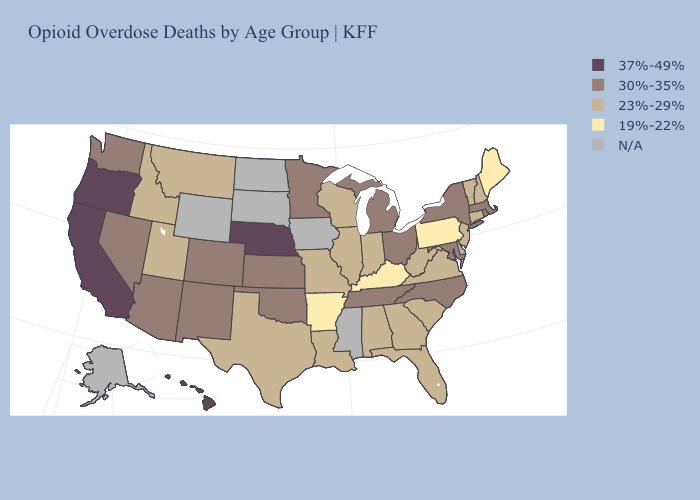Which states hav the highest value in the West?
Quick response, please. California, Hawaii, Oregon. What is the lowest value in the South?
Answer briefly. 19%-22%. Name the states that have a value in the range 30%-35%?
Be succinct. Arizona, Colorado, Kansas, Maryland, Massachusetts, Michigan, Minnesota, Nevada, New Mexico, New York, North Carolina, Ohio, Oklahoma, Rhode Island, Tennessee, Washington. Name the states that have a value in the range 23%-29%?
Quick response, please. Alabama, Connecticut, Florida, Georgia, Idaho, Illinois, Indiana, Louisiana, Missouri, Montana, New Hampshire, New Jersey, South Carolina, Texas, Utah, Vermont, Virginia, West Virginia, Wisconsin. Which states have the lowest value in the West?
Be succinct. Idaho, Montana, Utah. What is the value of Rhode Island?
Answer briefly. 30%-35%. Which states have the highest value in the USA?
Quick response, please. California, Hawaii, Nebraska, Oregon. Name the states that have a value in the range 30%-35%?
Be succinct. Arizona, Colorado, Kansas, Maryland, Massachusetts, Michigan, Minnesota, Nevada, New Mexico, New York, North Carolina, Ohio, Oklahoma, Rhode Island, Tennessee, Washington. What is the value of Minnesota?
Short answer required. 30%-35%. Name the states that have a value in the range 37%-49%?
Write a very short answer. California, Hawaii, Nebraska, Oregon. Name the states that have a value in the range 19%-22%?
Be succinct. Arkansas, Kentucky, Maine, Pennsylvania. What is the lowest value in the USA?
Quick response, please. 19%-22%. How many symbols are there in the legend?
Short answer required. 5. What is the highest value in the USA?
Short answer required. 37%-49%. 